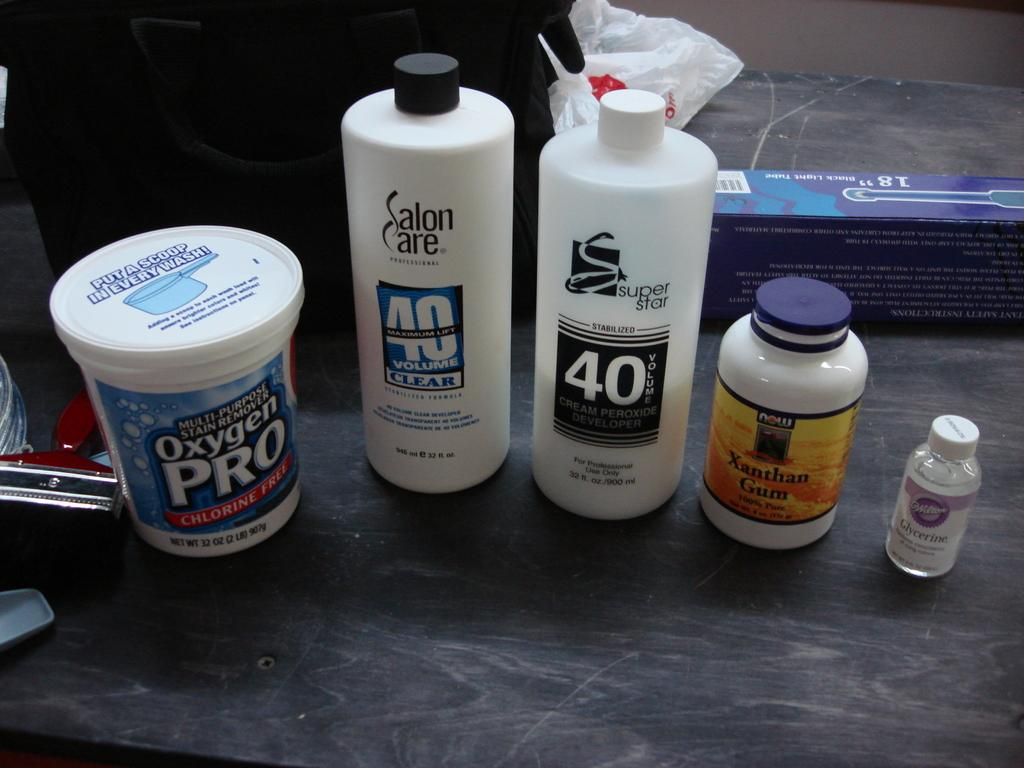<image>
Provide a brief description of the given image. are products Oxygen PRO, Salon Care 40 Volume Clear, super star 40, and Xanthan Gum on a flat surface. 